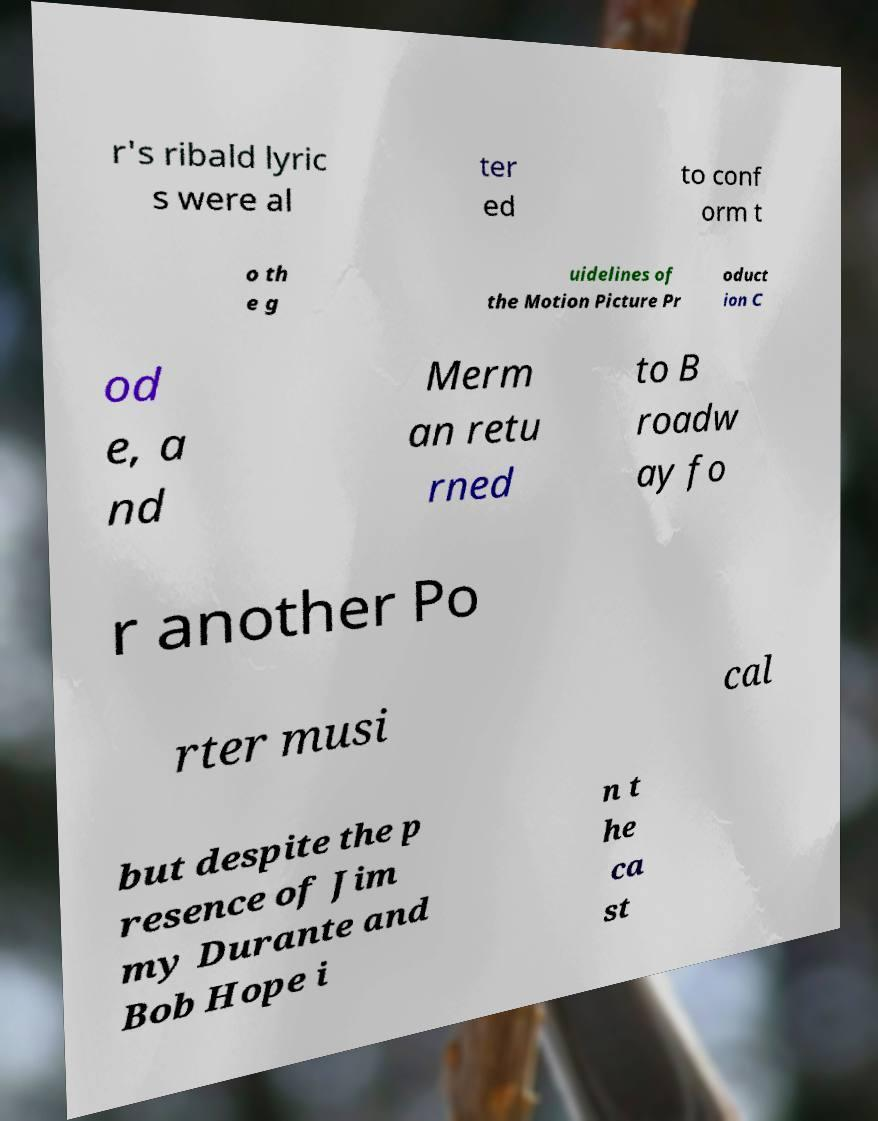Please read and relay the text visible in this image. What does it say? r's ribald lyric s were al ter ed to conf orm t o th e g uidelines of the Motion Picture Pr oduct ion C od e, a nd Merm an retu rned to B roadw ay fo r another Po rter musi cal but despite the p resence of Jim my Durante and Bob Hope i n t he ca st 